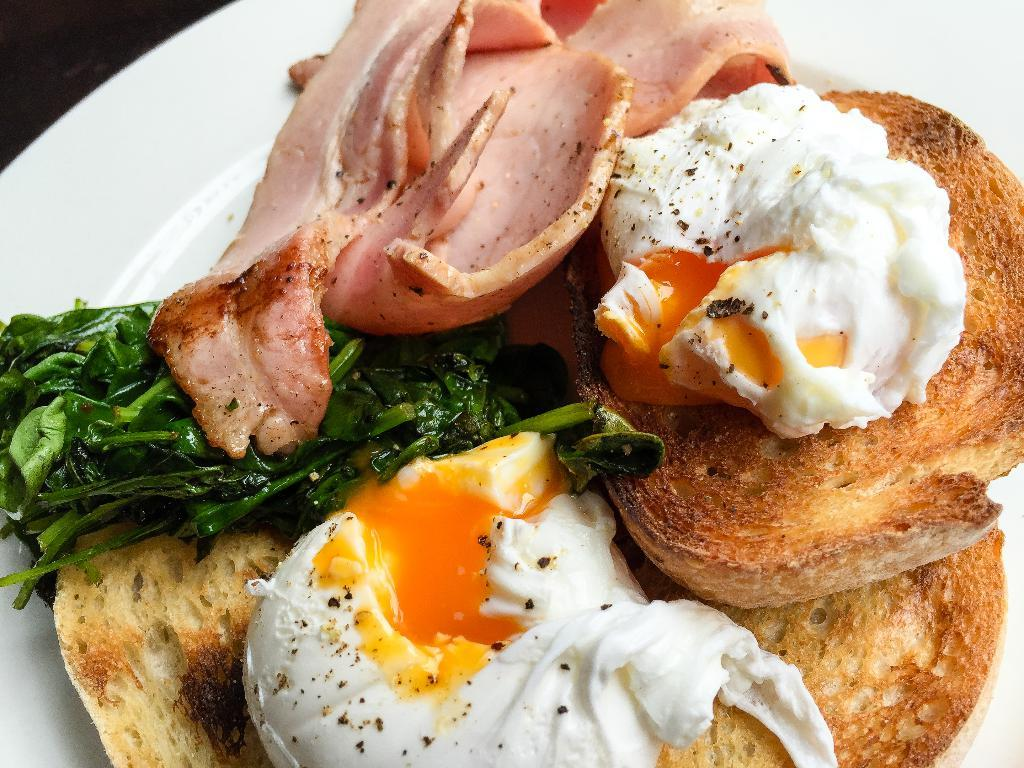What type of food can be seen in the image? There is meat in the image. What other items are present in the image besides the meat? There are leaves and toasted breads in the image. On what is the food placed? The food items are on a white color plate. How many tomatoes are being used as evidence in the crime scene depicted in the image? There is no crime scene or tomatoes present in the image; it features food items on a plate. Can you describe the rat that is hiding under the toasted bread in the image? There is no rat present in the image; it only contains food items on a plate. 